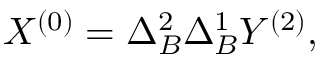Convert formula to latex. <formula><loc_0><loc_0><loc_500><loc_500>X ^ { ( 0 ) } = \Delta _ { B } ^ { 2 } \Delta _ { B } ^ { 1 } Y ^ { ( 2 ) } ,</formula> 